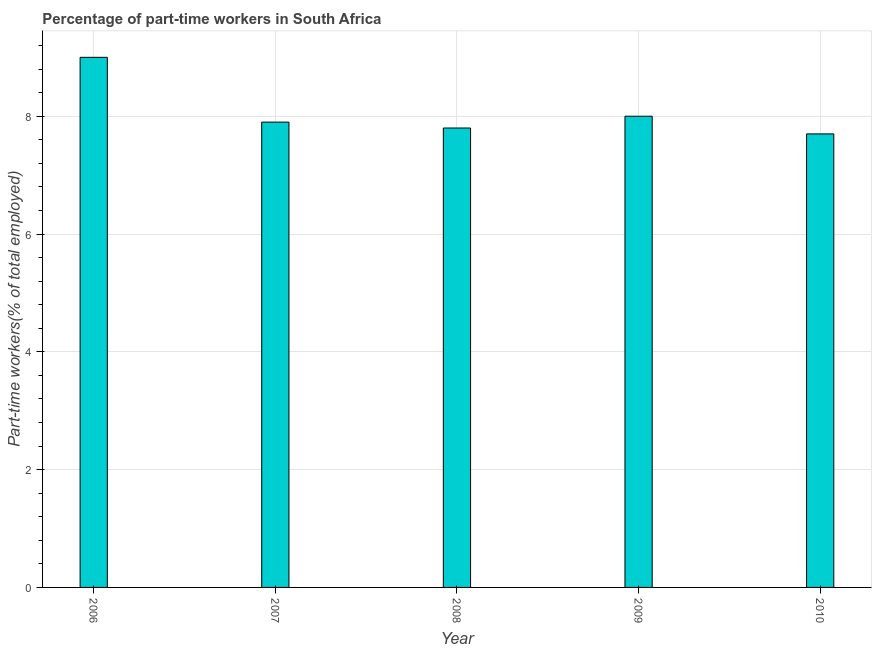Does the graph contain any zero values?
Provide a succinct answer. No. Does the graph contain grids?
Your response must be concise. Yes. What is the title of the graph?
Offer a terse response. Percentage of part-time workers in South Africa. What is the label or title of the X-axis?
Provide a succinct answer. Year. What is the label or title of the Y-axis?
Keep it short and to the point. Part-time workers(% of total employed). Across all years, what is the maximum percentage of part-time workers?
Your answer should be very brief. 9. Across all years, what is the minimum percentage of part-time workers?
Ensure brevity in your answer.  7.7. In which year was the percentage of part-time workers minimum?
Your answer should be compact. 2010. What is the sum of the percentage of part-time workers?
Your response must be concise. 40.4. What is the average percentage of part-time workers per year?
Ensure brevity in your answer.  8.08. What is the median percentage of part-time workers?
Your answer should be very brief. 7.9. Is the difference between the percentage of part-time workers in 2008 and 2010 greater than the difference between any two years?
Keep it short and to the point. No. What is the difference between the highest and the second highest percentage of part-time workers?
Provide a succinct answer. 1. Is the sum of the percentage of part-time workers in 2006 and 2007 greater than the maximum percentage of part-time workers across all years?
Keep it short and to the point. Yes. In how many years, is the percentage of part-time workers greater than the average percentage of part-time workers taken over all years?
Provide a short and direct response. 1. How many years are there in the graph?
Offer a very short reply. 5. What is the difference between two consecutive major ticks on the Y-axis?
Your response must be concise. 2. What is the Part-time workers(% of total employed) of 2007?
Keep it short and to the point. 7.9. What is the Part-time workers(% of total employed) in 2008?
Your answer should be compact. 7.8. What is the Part-time workers(% of total employed) in 2009?
Your answer should be very brief. 8. What is the Part-time workers(% of total employed) in 2010?
Give a very brief answer. 7.7. What is the difference between the Part-time workers(% of total employed) in 2006 and 2010?
Keep it short and to the point. 1.3. What is the difference between the Part-time workers(% of total employed) in 2007 and 2009?
Your answer should be compact. -0.1. What is the difference between the Part-time workers(% of total employed) in 2007 and 2010?
Your answer should be compact. 0.2. What is the difference between the Part-time workers(% of total employed) in 2009 and 2010?
Give a very brief answer. 0.3. What is the ratio of the Part-time workers(% of total employed) in 2006 to that in 2007?
Ensure brevity in your answer.  1.14. What is the ratio of the Part-time workers(% of total employed) in 2006 to that in 2008?
Provide a succinct answer. 1.15. What is the ratio of the Part-time workers(% of total employed) in 2006 to that in 2010?
Ensure brevity in your answer.  1.17. What is the ratio of the Part-time workers(% of total employed) in 2007 to that in 2008?
Your answer should be very brief. 1.01. What is the ratio of the Part-time workers(% of total employed) in 2007 to that in 2009?
Provide a succinct answer. 0.99. What is the ratio of the Part-time workers(% of total employed) in 2009 to that in 2010?
Provide a short and direct response. 1.04. 